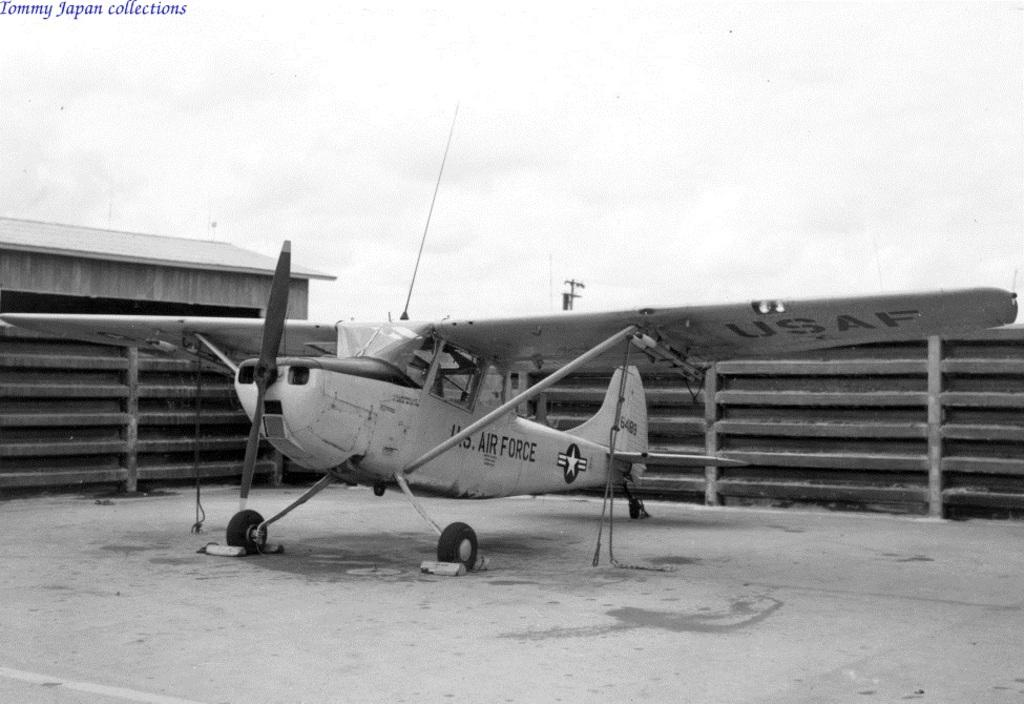<image>
Share a concise interpretation of the image provided. A picture of an old US Air Force plane no longer in operation can be seen 